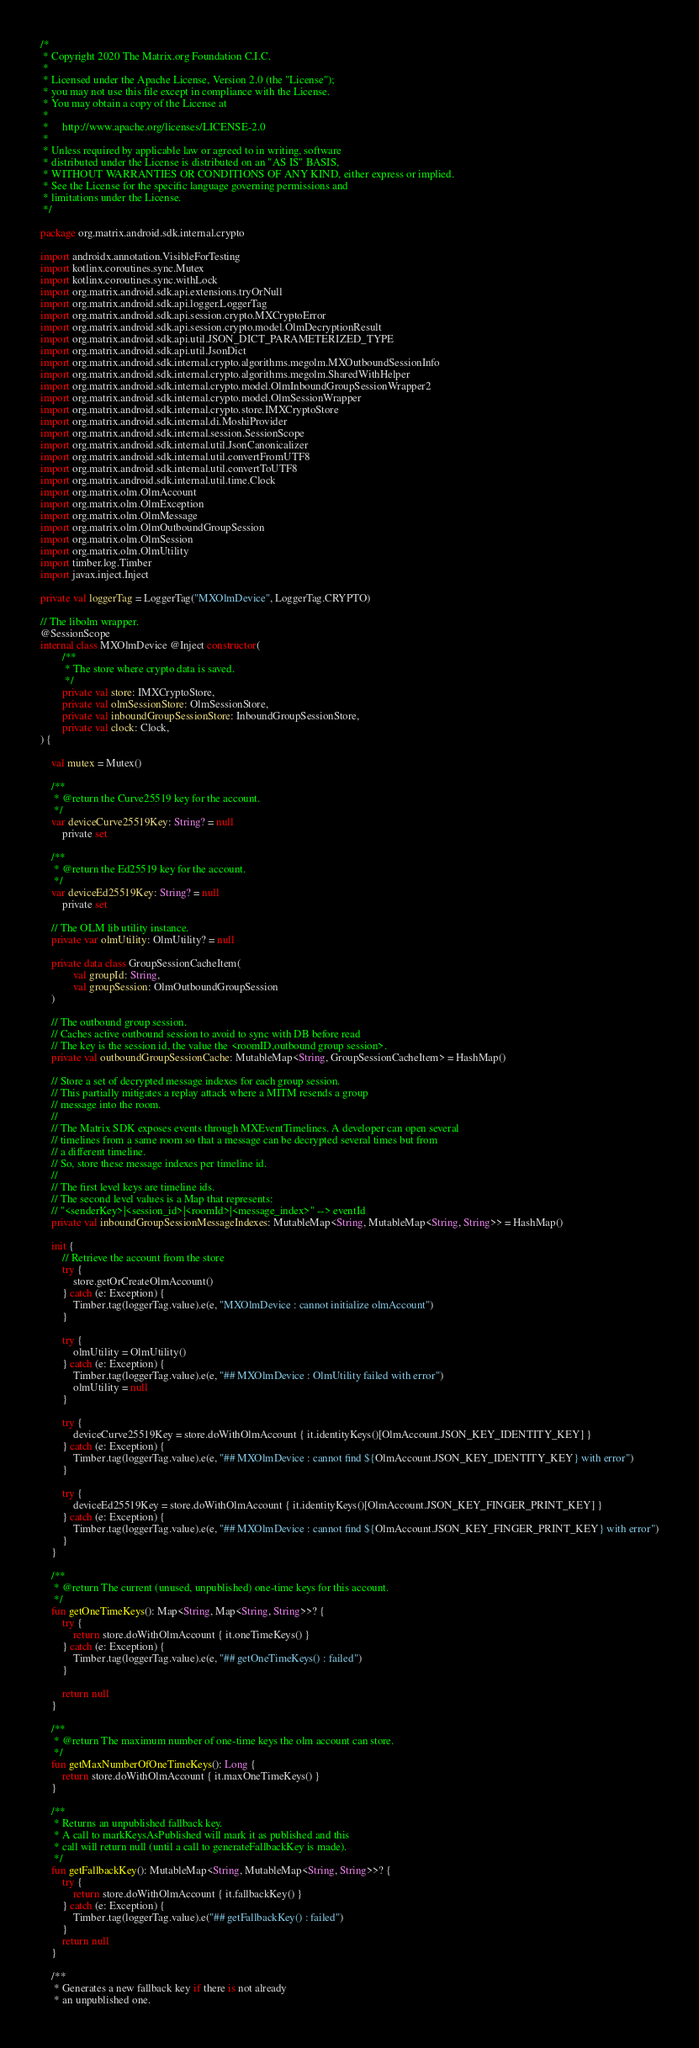Convert code to text. <code><loc_0><loc_0><loc_500><loc_500><_Kotlin_>/*
 * Copyright 2020 The Matrix.org Foundation C.I.C.
 *
 * Licensed under the Apache License, Version 2.0 (the "License");
 * you may not use this file except in compliance with the License.
 * You may obtain a copy of the License at
 *
 *     http://www.apache.org/licenses/LICENSE-2.0
 *
 * Unless required by applicable law or agreed to in writing, software
 * distributed under the License is distributed on an "AS IS" BASIS,
 * WITHOUT WARRANTIES OR CONDITIONS OF ANY KIND, either express or implied.
 * See the License for the specific language governing permissions and
 * limitations under the License.
 */

package org.matrix.android.sdk.internal.crypto

import androidx.annotation.VisibleForTesting
import kotlinx.coroutines.sync.Mutex
import kotlinx.coroutines.sync.withLock
import org.matrix.android.sdk.api.extensions.tryOrNull
import org.matrix.android.sdk.api.logger.LoggerTag
import org.matrix.android.sdk.api.session.crypto.MXCryptoError
import org.matrix.android.sdk.api.session.crypto.model.OlmDecryptionResult
import org.matrix.android.sdk.api.util.JSON_DICT_PARAMETERIZED_TYPE
import org.matrix.android.sdk.api.util.JsonDict
import org.matrix.android.sdk.internal.crypto.algorithms.megolm.MXOutboundSessionInfo
import org.matrix.android.sdk.internal.crypto.algorithms.megolm.SharedWithHelper
import org.matrix.android.sdk.internal.crypto.model.OlmInboundGroupSessionWrapper2
import org.matrix.android.sdk.internal.crypto.model.OlmSessionWrapper
import org.matrix.android.sdk.internal.crypto.store.IMXCryptoStore
import org.matrix.android.sdk.internal.di.MoshiProvider
import org.matrix.android.sdk.internal.session.SessionScope
import org.matrix.android.sdk.internal.util.JsonCanonicalizer
import org.matrix.android.sdk.internal.util.convertFromUTF8
import org.matrix.android.sdk.internal.util.convertToUTF8
import org.matrix.android.sdk.internal.util.time.Clock
import org.matrix.olm.OlmAccount
import org.matrix.olm.OlmException
import org.matrix.olm.OlmMessage
import org.matrix.olm.OlmOutboundGroupSession
import org.matrix.olm.OlmSession
import org.matrix.olm.OlmUtility
import timber.log.Timber
import javax.inject.Inject

private val loggerTag = LoggerTag("MXOlmDevice", LoggerTag.CRYPTO)

// The libolm wrapper.
@SessionScope
internal class MXOlmDevice @Inject constructor(
        /**
         * The store where crypto data is saved.
         */
        private val store: IMXCryptoStore,
        private val olmSessionStore: OlmSessionStore,
        private val inboundGroupSessionStore: InboundGroupSessionStore,
        private val clock: Clock,
) {

    val mutex = Mutex()

    /**
     * @return the Curve25519 key for the account.
     */
    var deviceCurve25519Key: String? = null
        private set

    /**
     * @return the Ed25519 key for the account.
     */
    var deviceEd25519Key: String? = null
        private set

    // The OLM lib utility instance.
    private var olmUtility: OlmUtility? = null

    private data class GroupSessionCacheItem(
            val groupId: String,
            val groupSession: OlmOutboundGroupSession
    )

    // The outbound group session.
    // Caches active outbound session to avoid to sync with DB before read
    // The key is the session id, the value the <roomID,outbound group session>.
    private val outboundGroupSessionCache: MutableMap<String, GroupSessionCacheItem> = HashMap()

    // Store a set of decrypted message indexes for each group session.
    // This partially mitigates a replay attack where a MITM resends a group
    // message into the room.
    //
    // The Matrix SDK exposes events through MXEventTimelines. A developer can open several
    // timelines from a same room so that a message can be decrypted several times but from
    // a different timeline.
    // So, store these message indexes per timeline id.
    //
    // The first level keys are timeline ids.
    // The second level values is a Map that represents:
    // "<senderKey>|<session_id>|<roomId>|<message_index>" --> eventId
    private val inboundGroupSessionMessageIndexes: MutableMap<String, MutableMap<String, String>> = HashMap()

    init {
        // Retrieve the account from the store
        try {
            store.getOrCreateOlmAccount()
        } catch (e: Exception) {
            Timber.tag(loggerTag.value).e(e, "MXOlmDevice : cannot initialize olmAccount")
        }

        try {
            olmUtility = OlmUtility()
        } catch (e: Exception) {
            Timber.tag(loggerTag.value).e(e, "## MXOlmDevice : OlmUtility failed with error")
            olmUtility = null
        }

        try {
            deviceCurve25519Key = store.doWithOlmAccount { it.identityKeys()[OlmAccount.JSON_KEY_IDENTITY_KEY] }
        } catch (e: Exception) {
            Timber.tag(loggerTag.value).e(e, "## MXOlmDevice : cannot find ${OlmAccount.JSON_KEY_IDENTITY_KEY} with error")
        }

        try {
            deviceEd25519Key = store.doWithOlmAccount { it.identityKeys()[OlmAccount.JSON_KEY_FINGER_PRINT_KEY] }
        } catch (e: Exception) {
            Timber.tag(loggerTag.value).e(e, "## MXOlmDevice : cannot find ${OlmAccount.JSON_KEY_FINGER_PRINT_KEY} with error")
        }
    }

    /**
     * @return The current (unused, unpublished) one-time keys for this account.
     */
    fun getOneTimeKeys(): Map<String, Map<String, String>>? {
        try {
            return store.doWithOlmAccount { it.oneTimeKeys() }
        } catch (e: Exception) {
            Timber.tag(loggerTag.value).e(e, "## getOneTimeKeys() : failed")
        }

        return null
    }

    /**
     * @return The maximum number of one-time keys the olm account can store.
     */
    fun getMaxNumberOfOneTimeKeys(): Long {
        return store.doWithOlmAccount { it.maxOneTimeKeys() }
    }

    /**
     * Returns an unpublished fallback key.
     * A call to markKeysAsPublished will mark it as published and this
     * call will return null (until a call to generateFallbackKey is made).
     */
    fun getFallbackKey(): MutableMap<String, MutableMap<String, String>>? {
        try {
            return store.doWithOlmAccount { it.fallbackKey() }
        } catch (e: Exception) {
            Timber.tag(loggerTag.value).e("## getFallbackKey() : failed")
        }
        return null
    }

    /**
     * Generates a new fallback key if there is not already
     * an unpublished one.</code> 